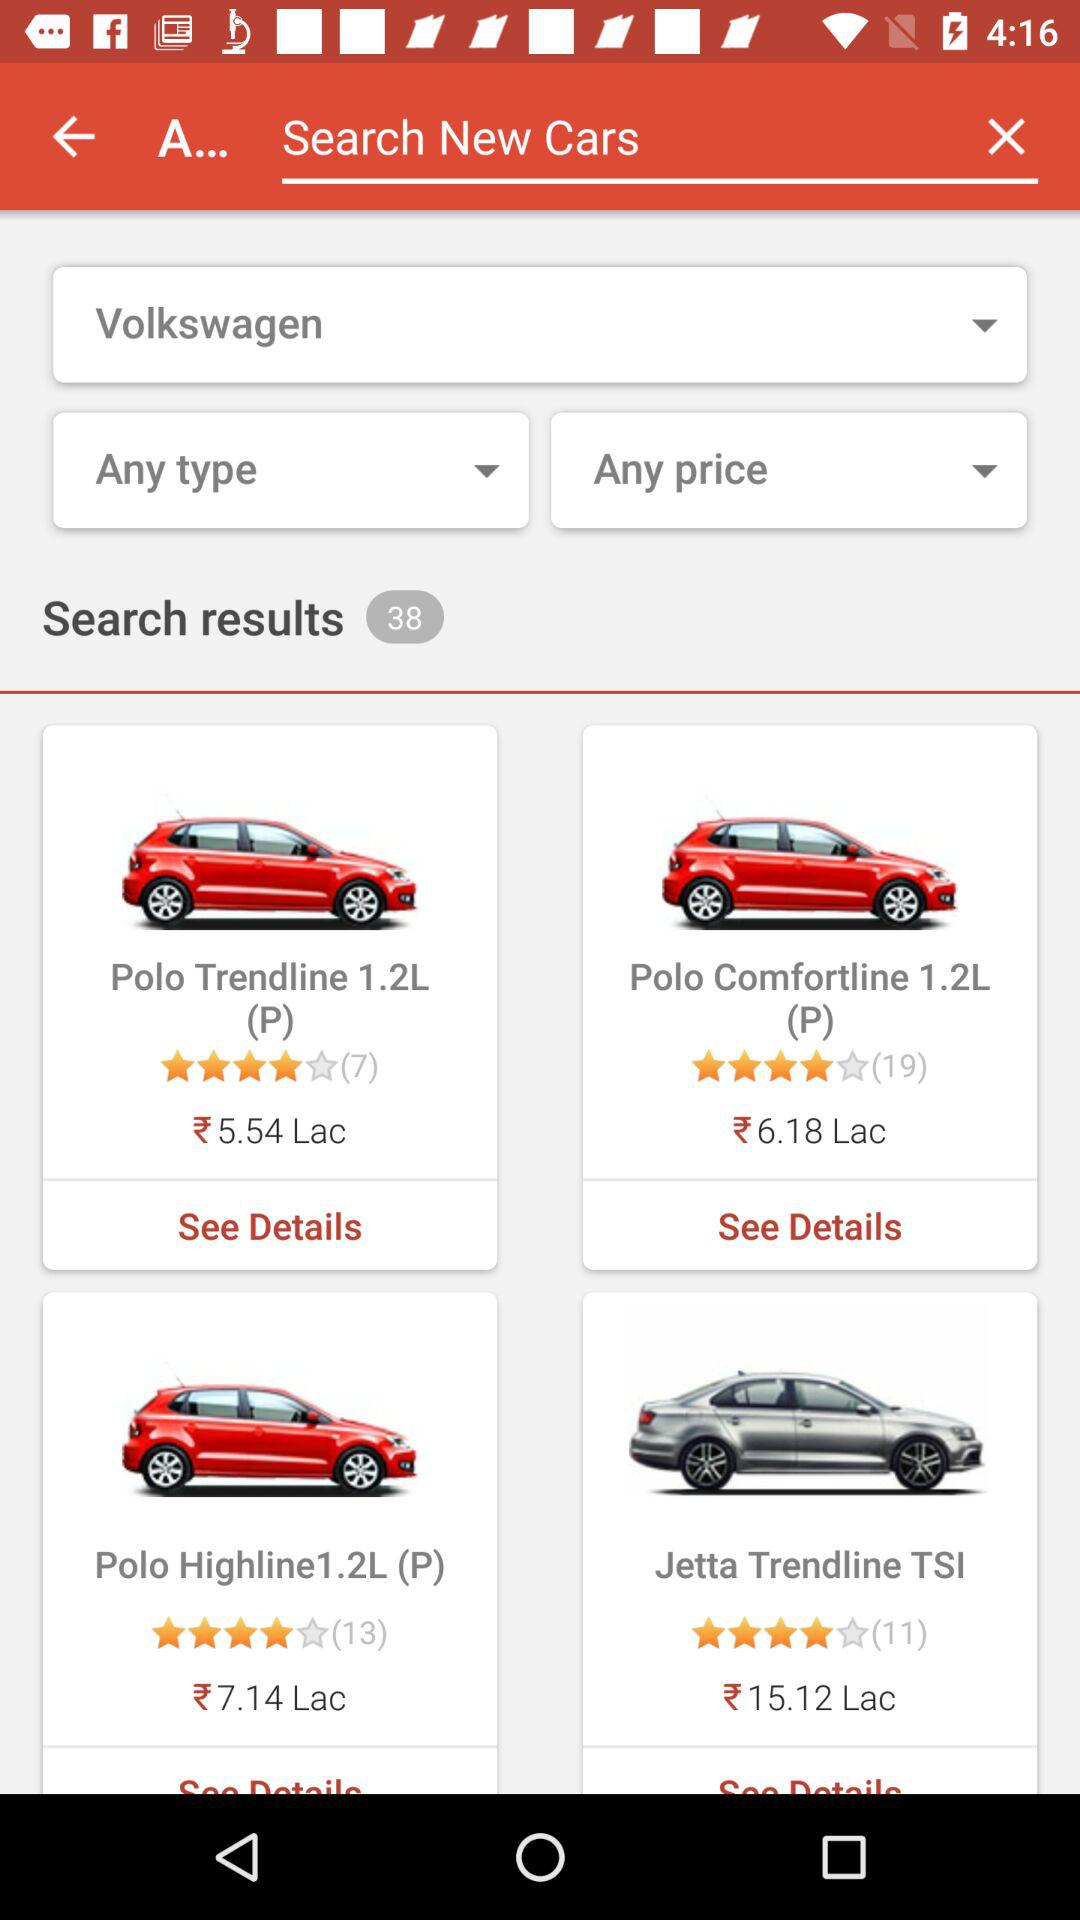What are the total results of the search? The total number of search results is 38. 